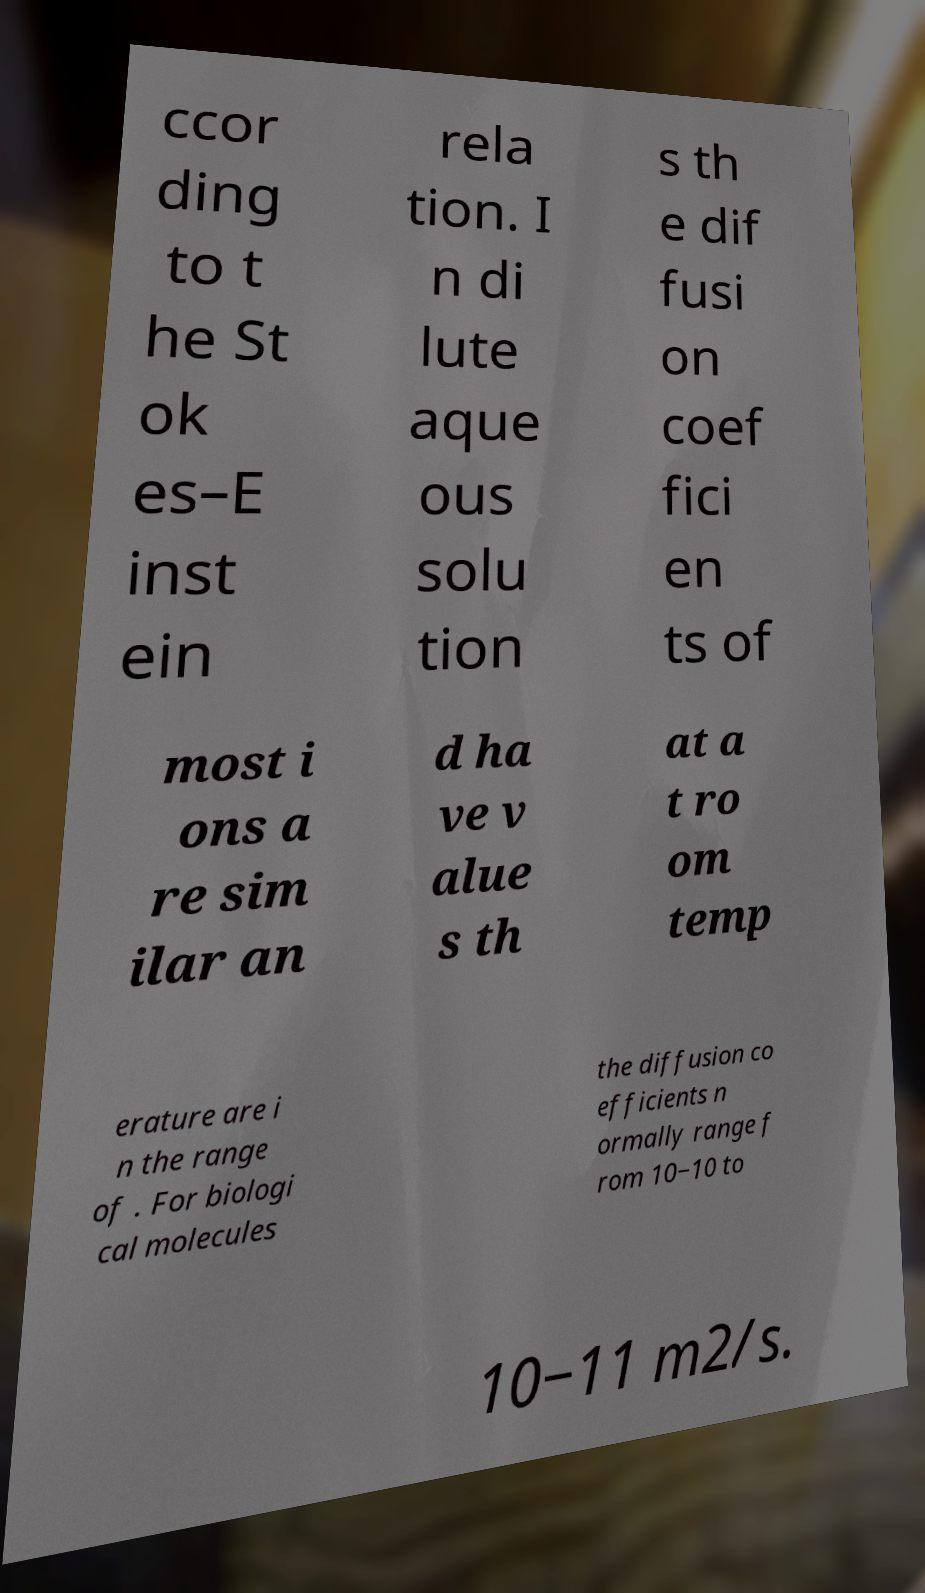Please read and relay the text visible in this image. What does it say? ccor ding to t he St ok es–E inst ein rela tion. I n di lute aque ous solu tion s th e dif fusi on coef fici en ts of most i ons a re sim ilar an d ha ve v alue s th at a t ro om temp erature are i n the range of . For biologi cal molecules the diffusion co efficients n ormally range f rom 10−10 to 10−11 m2/s. 